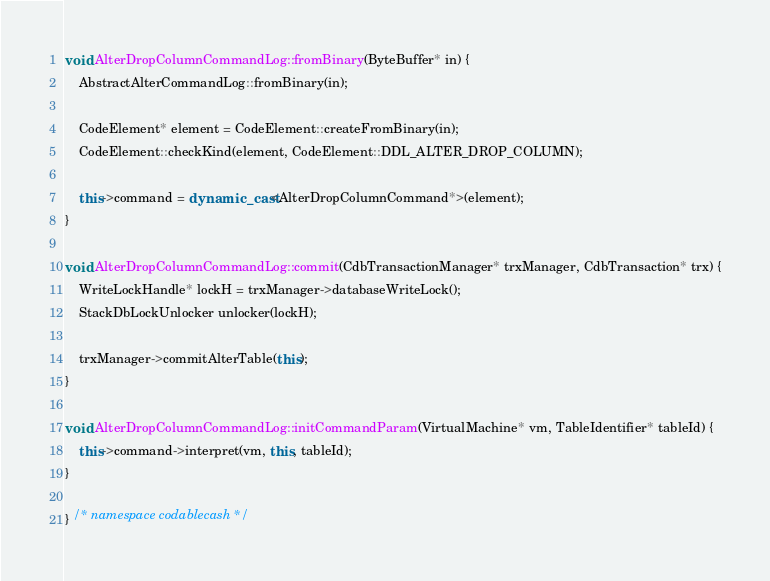<code> <loc_0><loc_0><loc_500><loc_500><_C++_>void AlterDropColumnCommandLog::fromBinary(ByteBuffer* in) {
	AbstractAlterCommandLog::fromBinary(in);

	CodeElement* element = CodeElement::createFromBinary(in);
	CodeElement::checkKind(element, CodeElement::DDL_ALTER_DROP_COLUMN);

	this->command = dynamic_cast<AlterDropColumnCommand*>(element);
}

void AlterDropColumnCommandLog::commit(CdbTransactionManager* trxManager, CdbTransaction* trx) {
	WriteLockHandle* lockH = trxManager->databaseWriteLock();
	StackDbLockUnlocker unlocker(lockH);

	trxManager->commitAlterTable(this);
}

void AlterDropColumnCommandLog::initCommandParam(VirtualMachine* vm, TableIdentifier* tableId) {
	this->command->interpret(vm, this, tableId);
}

} /* namespace codablecash */
</code> 